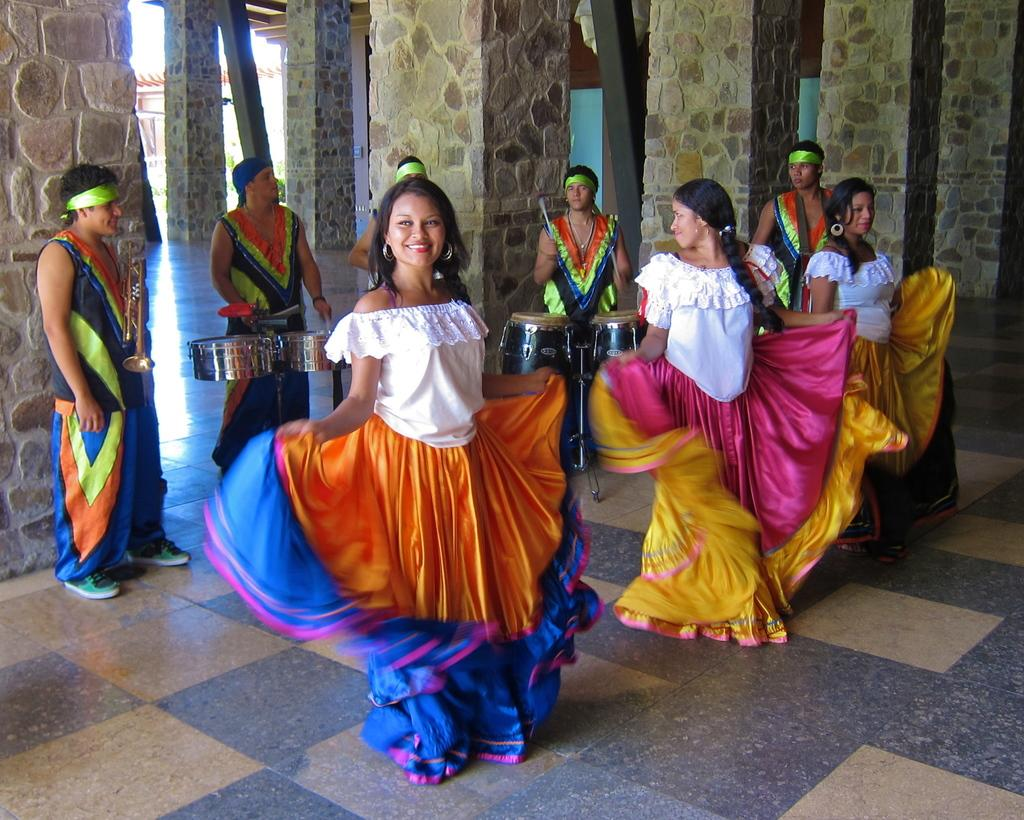What are the people in the image doing? There are people dancing on the floor and playing drums. Can you describe the setting of the image? There are pillars of a building visible in the background. What type of distribution system is being used to supply water to the people in the image? There is no mention of a water distribution system in the image, as it focuses on people dancing and playing drums. --- Facts: 1. There is a person sitting on a chair. 2. The person is holding a book. 3. There is a table next to the chair. 4. There is a lamp on the table. Absurd Topics: parrot, ocean, bicycle Conversation: What is the person in the image doing? The person is sitting on a chair and holding a book. What object is next to the chair? There is a table next to the chair. What is on the table? There is a lamp on the table. Reasoning: Let's think step by step in order to produce the conversation. We start by identifying the main subject in the image, which is the person sitting on a chair. Then, we expand the conversation to include other items that are also visible, such as the book, table, and lamp. Each question is designed to elicit a specific detail about the image that is known from the provided facts. Absurd Question/Answer: Can you see a parrot flying over the ocean in the image? There is no parrot or ocean present in the image; it features a person sitting on a chair holding a book, with a table and lamp nearby. 